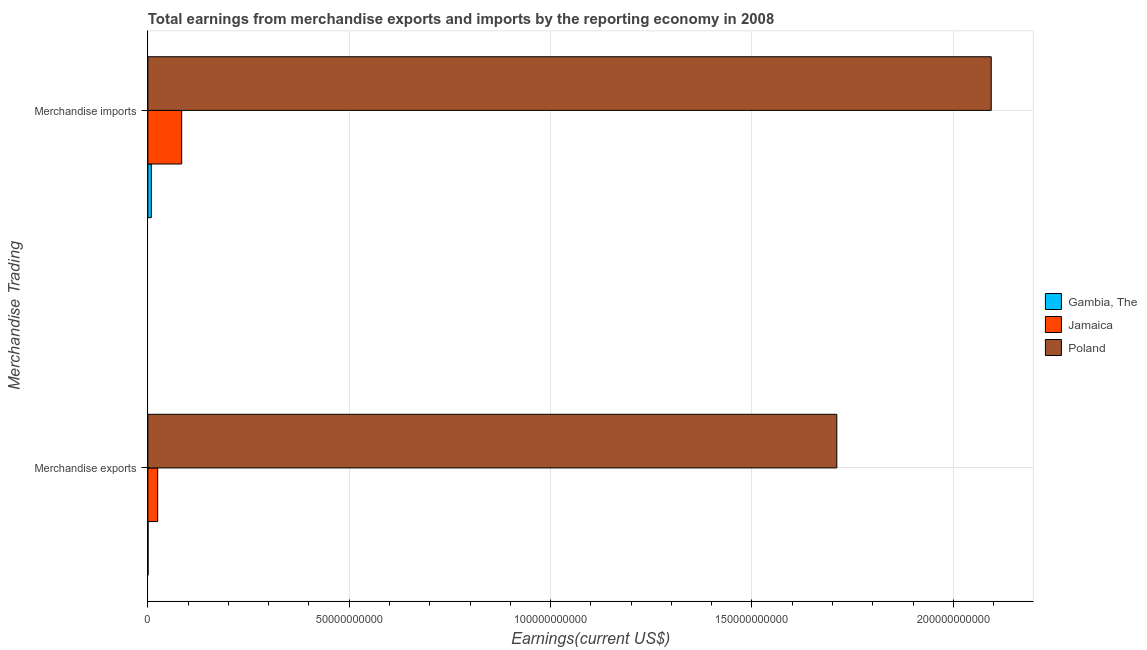Are the number of bars per tick equal to the number of legend labels?
Provide a short and direct response. Yes. What is the earnings from merchandise exports in Jamaica?
Offer a very short reply. 2.44e+09. Across all countries, what is the maximum earnings from merchandise imports?
Make the answer very short. 2.09e+11. Across all countries, what is the minimum earnings from merchandise exports?
Offer a terse response. 5.09e+07. In which country was the earnings from merchandise exports minimum?
Your answer should be very brief. Gambia, The. What is the total earnings from merchandise imports in the graph?
Keep it short and to the point. 2.19e+11. What is the difference between the earnings from merchandise exports in Poland and that in Gambia, The?
Make the answer very short. 1.71e+11. What is the difference between the earnings from merchandise exports in Poland and the earnings from merchandise imports in Gambia, The?
Keep it short and to the point. 1.70e+11. What is the average earnings from merchandise imports per country?
Give a very brief answer. 7.29e+1. What is the difference between the earnings from merchandise exports and earnings from merchandise imports in Poland?
Your answer should be compact. -3.83e+1. In how many countries, is the earnings from merchandise exports greater than 180000000000 US$?
Provide a succinct answer. 0. What is the ratio of the earnings from merchandise exports in Poland to that in Gambia, The?
Ensure brevity in your answer.  3360.12. In how many countries, is the earnings from merchandise imports greater than the average earnings from merchandise imports taken over all countries?
Keep it short and to the point. 1. What does the 3rd bar from the top in Merchandise exports represents?
Keep it short and to the point. Gambia, The. What does the 1st bar from the bottom in Merchandise imports represents?
Make the answer very short. Gambia, The. Are the values on the major ticks of X-axis written in scientific E-notation?
Provide a short and direct response. No. Does the graph contain any zero values?
Keep it short and to the point. No. Does the graph contain grids?
Make the answer very short. Yes. Where does the legend appear in the graph?
Your answer should be compact. Center right. How many legend labels are there?
Offer a terse response. 3. How are the legend labels stacked?
Provide a succinct answer. Vertical. What is the title of the graph?
Provide a short and direct response. Total earnings from merchandise exports and imports by the reporting economy in 2008. What is the label or title of the X-axis?
Your response must be concise. Earnings(current US$). What is the label or title of the Y-axis?
Keep it short and to the point. Merchandise Trading. What is the Earnings(current US$) of Gambia, The in Merchandise exports?
Give a very brief answer. 5.09e+07. What is the Earnings(current US$) of Jamaica in Merchandise exports?
Your answer should be compact. 2.44e+09. What is the Earnings(current US$) in Poland in Merchandise exports?
Ensure brevity in your answer.  1.71e+11. What is the Earnings(current US$) of Gambia, The in Merchandise imports?
Your answer should be very brief. 8.60e+08. What is the Earnings(current US$) in Jamaica in Merchandise imports?
Make the answer very short. 8.40e+09. What is the Earnings(current US$) of Poland in Merchandise imports?
Keep it short and to the point. 2.09e+11. Across all Merchandise Trading, what is the maximum Earnings(current US$) in Gambia, The?
Offer a very short reply. 8.60e+08. Across all Merchandise Trading, what is the maximum Earnings(current US$) in Jamaica?
Offer a very short reply. 8.40e+09. Across all Merchandise Trading, what is the maximum Earnings(current US$) of Poland?
Provide a short and direct response. 2.09e+11. Across all Merchandise Trading, what is the minimum Earnings(current US$) in Gambia, The?
Your answer should be compact. 5.09e+07. Across all Merchandise Trading, what is the minimum Earnings(current US$) of Jamaica?
Give a very brief answer. 2.44e+09. Across all Merchandise Trading, what is the minimum Earnings(current US$) in Poland?
Your answer should be very brief. 1.71e+11. What is the total Earnings(current US$) in Gambia, The in the graph?
Offer a very short reply. 9.11e+08. What is the total Earnings(current US$) in Jamaica in the graph?
Your answer should be very brief. 1.08e+1. What is the total Earnings(current US$) in Poland in the graph?
Keep it short and to the point. 3.80e+11. What is the difference between the Earnings(current US$) of Gambia, The in Merchandise exports and that in Merchandise imports?
Provide a succinct answer. -8.09e+08. What is the difference between the Earnings(current US$) in Jamaica in Merchandise exports and that in Merchandise imports?
Keep it short and to the point. -5.96e+09. What is the difference between the Earnings(current US$) of Poland in Merchandise exports and that in Merchandise imports?
Ensure brevity in your answer.  -3.83e+1. What is the difference between the Earnings(current US$) of Gambia, The in Merchandise exports and the Earnings(current US$) of Jamaica in Merchandise imports?
Make the answer very short. -8.35e+09. What is the difference between the Earnings(current US$) of Gambia, The in Merchandise exports and the Earnings(current US$) of Poland in Merchandise imports?
Provide a short and direct response. -2.09e+11. What is the difference between the Earnings(current US$) in Jamaica in Merchandise exports and the Earnings(current US$) in Poland in Merchandise imports?
Provide a short and direct response. -2.07e+11. What is the average Earnings(current US$) in Gambia, The per Merchandise Trading?
Your answer should be compact. 4.56e+08. What is the average Earnings(current US$) of Jamaica per Merchandise Trading?
Make the answer very short. 5.42e+09. What is the average Earnings(current US$) of Poland per Merchandise Trading?
Make the answer very short. 1.90e+11. What is the difference between the Earnings(current US$) in Gambia, The and Earnings(current US$) in Jamaica in Merchandise exports?
Provide a succinct answer. -2.39e+09. What is the difference between the Earnings(current US$) in Gambia, The and Earnings(current US$) in Poland in Merchandise exports?
Make the answer very short. -1.71e+11. What is the difference between the Earnings(current US$) in Jamaica and Earnings(current US$) in Poland in Merchandise exports?
Offer a terse response. -1.69e+11. What is the difference between the Earnings(current US$) in Gambia, The and Earnings(current US$) in Jamaica in Merchandise imports?
Offer a terse response. -7.54e+09. What is the difference between the Earnings(current US$) of Gambia, The and Earnings(current US$) of Poland in Merchandise imports?
Your answer should be very brief. -2.09e+11. What is the difference between the Earnings(current US$) in Jamaica and Earnings(current US$) in Poland in Merchandise imports?
Your response must be concise. -2.01e+11. What is the ratio of the Earnings(current US$) in Gambia, The in Merchandise exports to that in Merchandise imports?
Provide a short and direct response. 0.06. What is the ratio of the Earnings(current US$) in Jamaica in Merchandise exports to that in Merchandise imports?
Give a very brief answer. 0.29. What is the ratio of the Earnings(current US$) in Poland in Merchandise exports to that in Merchandise imports?
Your response must be concise. 0.82. What is the difference between the highest and the second highest Earnings(current US$) of Gambia, The?
Provide a short and direct response. 8.09e+08. What is the difference between the highest and the second highest Earnings(current US$) in Jamaica?
Make the answer very short. 5.96e+09. What is the difference between the highest and the second highest Earnings(current US$) in Poland?
Your answer should be very brief. 3.83e+1. What is the difference between the highest and the lowest Earnings(current US$) of Gambia, The?
Give a very brief answer. 8.09e+08. What is the difference between the highest and the lowest Earnings(current US$) of Jamaica?
Provide a succinct answer. 5.96e+09. What is the difference between the highest and the lowest Earnings(current US$) of Poland?
Make the answer very short. 3.83e+1. 